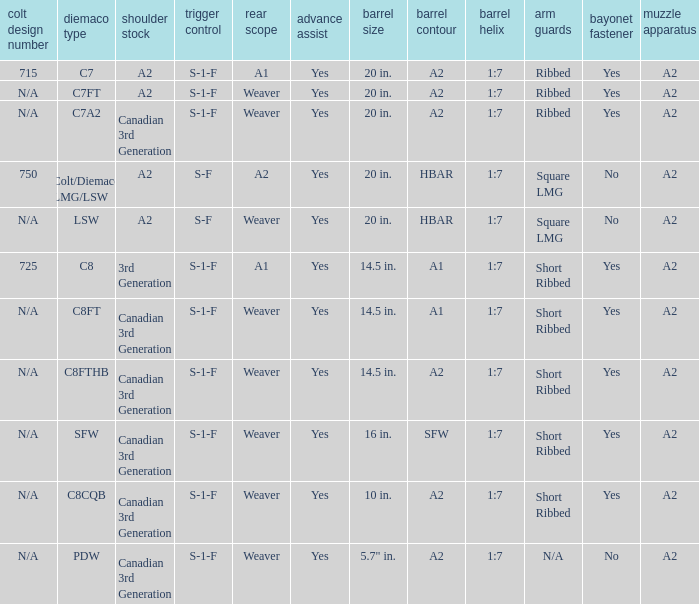I'm looking to parse the entire table for insights. Could you assist me with that? {'header': ['colt design number', 'diemaco type', 'shoulder stock', 'trigger control', 'rear scope', 'advance assist', 'barrel size', 'barrel contour', 'barrel helix', 'arm guards', 'bayonet fastener', 'muzzle apparatus'], 'rows': [['715', 'C7', 'A2', 'S-1-F', 'A1', 'Yes', '20 in.', 'A2', '1:7', 'Ribbed', 'Yes', 'A2'], ['N/A', 'C7FT', 'A2', 'S-1-F', 'Weaver', 'Yes', '20 in.', 'A2', '1:7', 'Ribbed', 'Yes', 'A2'], ['N/A', 'C7A2', 'Canadian 3rd Generation', 'S-1-F', 'Weaver', 'Yes', '20 in.', 'A2', '1:7', 'Ribbed', 'Yes', 'A2'], ['750', 'Colt/Diemaco LMG/LSW', 'A2', 'S-F', 'A2', 'Yes', '20 in.', 'HBAR', '1:7', 'Square LMG', 'No', 'A2'], ['N/A', 'LSW', 'A2', 'S-F', 'Weaver', 'Yes', '20 in.', 'HBAR', '1:7', 'Square LMG', 'No', 'A2'], ['725', 'C8', '3rd Generation', 'S-1-F', 'A1', 'Yes', '14.5 in.', 'A1', '1:7', 'Short Ribbed', 'Yes', 'A2'], ['N/A', 'C8FT', 'Canadian 3rd Generation', 'S-1-F', 'Weaver', 'Yes', '14.5 in.', 'A1', '1:7', 'Short Ribbed', 'Yes', 'A2'], ['N/A', 'C8FTHB', 'Canadian 3rd Generation', 'S-1-F', 'Weaver', 'Yes', '14.5 in.', 'A2', '1:7', 'Short Ribbed', 'Yes', 'A2'], ['N/A', 'SFW', 'Canadian 3rd Generation', 'S-1-F', 'Weaver', 'Yes', '16 in.', 'SFW', '1:7', 'Short Ribbed', 'Yes', 'A2'], ['N/A', 'C8CQB', 'Canadian 3rd Generation', 'S-1-F', 'Weaver', 'Yes', '10 in.', 'A2', '1:7', 'Short Ribbed', 'Yes', 'A2'], ['N/A', 'PDW', 'Canadian 3rd Generation', 'S-1-F', 'Weaver', 'Yes', '5.7" in.', 'A2', '1:7', 'N/A', 'No', 'A2']]} Which Hand guards has a Barrel profile of a2 and a Rear sight of weaver? Ribbed, Ribbed, Short Ribbed, Short Ribbed, N/A. 